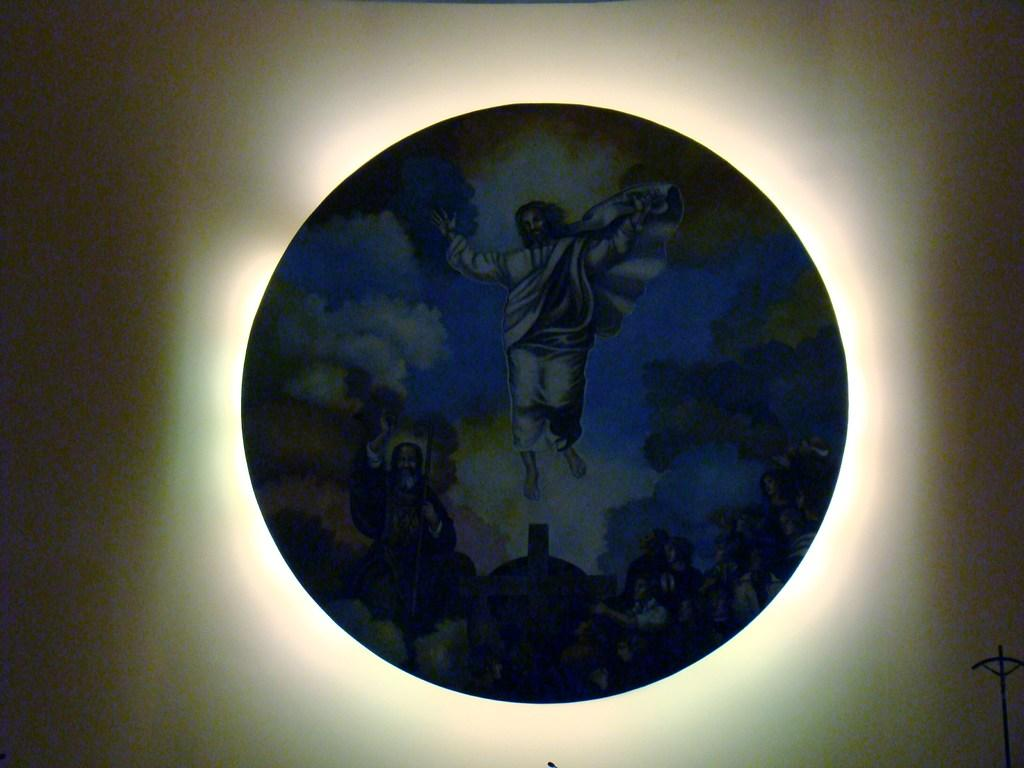What is the main subject of the image? The main subject of the image is a picture of Jesus. What is the shape of the object on which the picture of Jesus is placed? The object is round-shaped. Can you tell me how many arms are visible in the image? There is no reference to any arms in the image, as it features a picture of Jesus on a round-shaped object. 